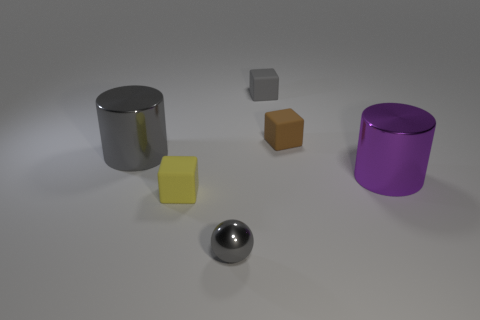Add 1 blue metal cubes. How many objects exist? 7 Subtract all cylinders. How many objects are left? 4 Subtract 1 purple cylinders. How many objects are left? 5 Subtract all gray blocks. Subtract all cylinders. How many objects are left? 3 Add 4 large metal objects. How many large metal objects are left? 6 Add 3 large green objects. How many large green objects exist? 3 